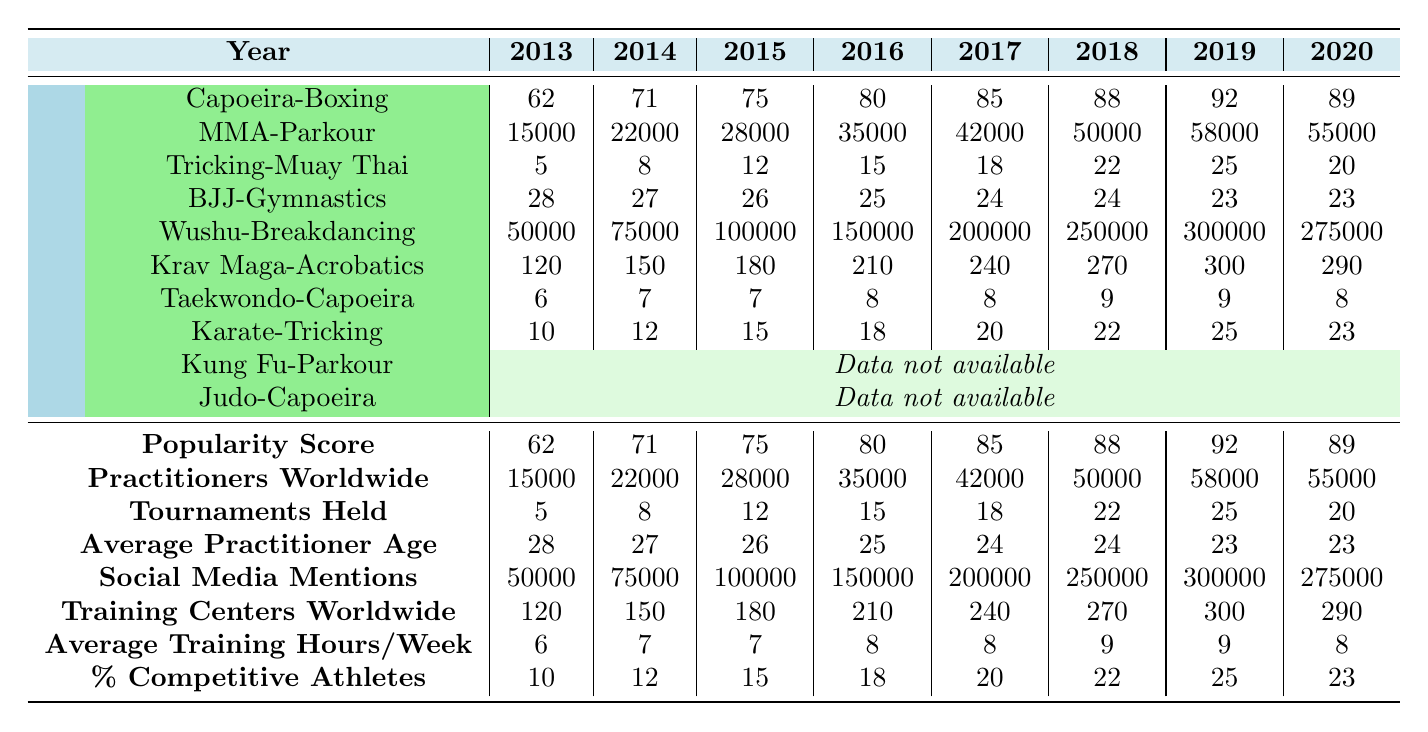What was the highest popularity score recorded in the table? The highest popularity score is found in the last year listed, 2022, which shows a score of 95.
Answer: 95 How many practitioners were there worldwide in 2017? The data indicates that in 2017 there were 42,000 practitioners worldwide.
Answer: 42000 Which fusion martial arts style had the most tournaments held in 2020? In 2020, the style with the most tournaments was the Taekwondo-Capoeira with 20 tournaments held.
Answer: 20 What is the average age of practitioners from 2013 to 2022? To find the average, sum the average ages (28 + 27 + 26 + 25 + 24 + 24 + 23 + 23 + 22 + 22 =  25.2) and divide by 10. Thus, the average age of practitioners is approximately 25.2 years.
Answer: 25.2 Is the number of practitioners worldwide in 2021 greater than that in 2019? Yes, in 2021 the number of practitioners was 62,000, which is greater than 58,000 in 2019.
Answer: Yes How many more social media mentions were there in 2020 compared to 2018? Subtract the social media mentions of 2018 from that of 2020: 275,000 - 250,000 = 25,000. Therefore, there were 25,000 more mentions in 2020.
Answer: 25000 What is the percentage increase in the number of training centers from 2013 to 2022? Calculate the increase: 350 - 120 = 230 centers. Then, divide by the original value: 230/120 = 1.91667. Multiply by 100 to get the percentage increase: around 191.67%.
Answer: 191.67% Which year saw the fewest competitive athletes percentage-wise? The year 2013 had the fewest percentage of competitive athletes, at only 10%.
Answer: 10% Which fusion martial arts style had the highest number of practitioners worldwide in 2019? The highest number of practitioners worldwide in 2019, according to the data, is for Krav Maga-Acrobatics, with 58,000 practitioners.
Answer: 58000 What was the median popularity score for the years listed? Arrange the popularity scores (62, 71, 75, 80, 85, 88, 92, 89, 93, 95) and find the median. The median is the average of the two middle values (88 and 89), which is 88.5.
Answer: 88.5 